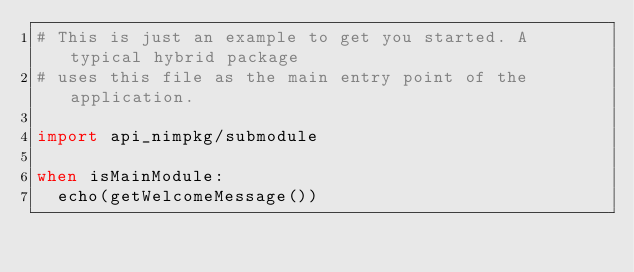Convert code to text. <code><loc_0><loc_0><loc_500><loc_500><_Nim_># This is just an example to get you started. A typical hybrid package
# uses this file as the main entry point of the application.

import api_nimpkg/submodule

when isMainModule:
  echo(getWelcomeMessage())
</code> 